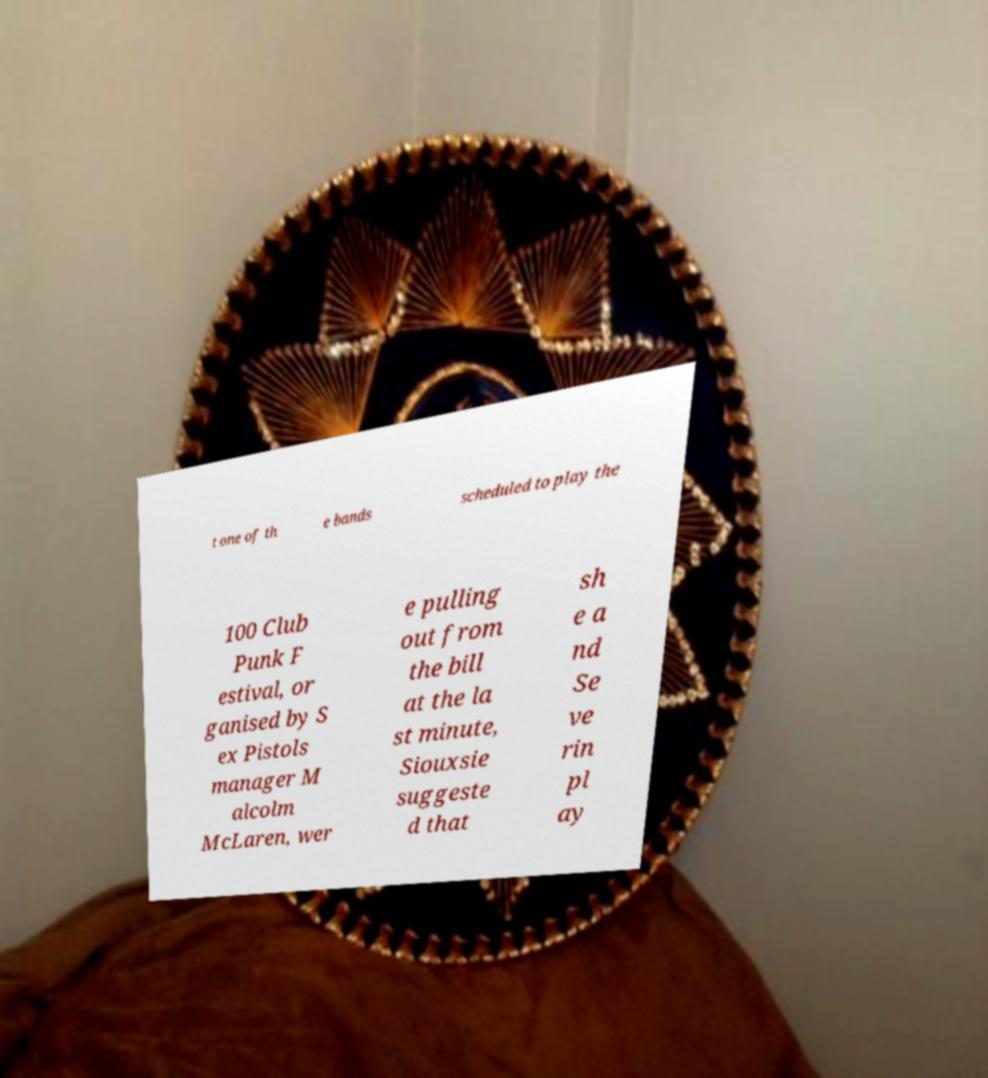Can you accurately transcribe the text from the provided image for me? t one of th e bands scheduled to play the 100 Club Punk F estival, or ganised by S ex Pistols manager M alcolm McLaren, wer e pulling out from the bill at the la st minute, Siouxsie suggeste d that sh e a nd Se ve rin pl ay 